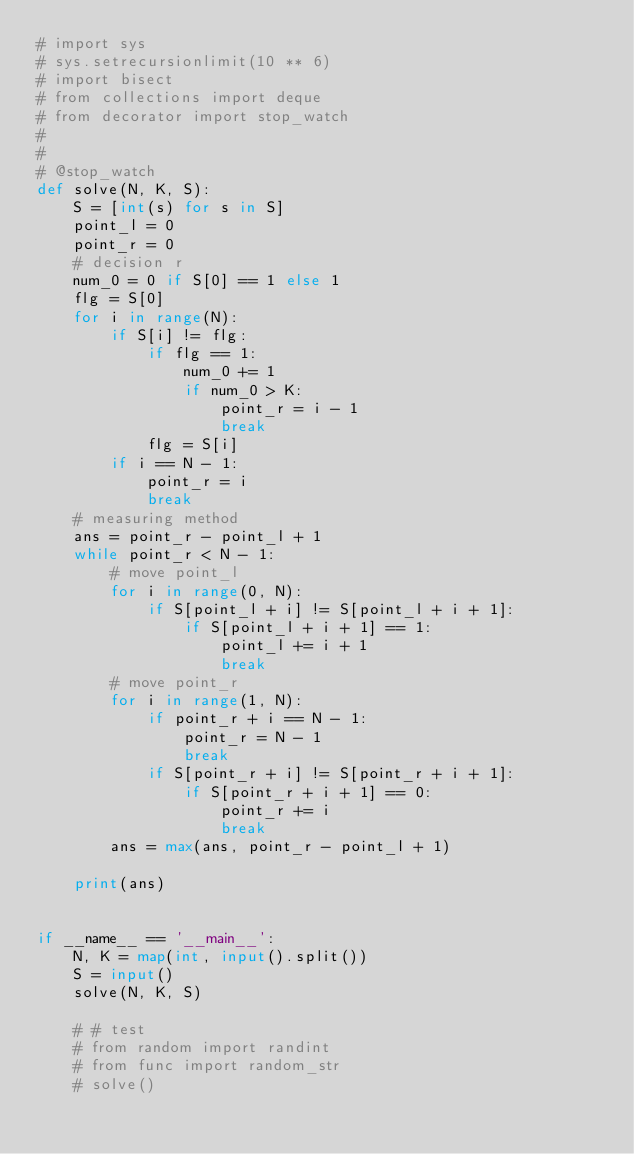<code> <loc_0><loc_0><loc_500><loc_500><_Python_># import sys
# sys.setrecursionlimit(10 ** 6)
# import bisect
# from collections import deque
# from decorator import stop_watch
# 
# 
# @stop_watch
def solve(N, K, S):
    S = [int(s) for s in S]
    point_l = 0
    point_r = 0
    # decision r
    num_0 = 0 if S[0] == 1 else 1
    flg = S[0]
    for i in range(N):
        if S[i] != flg:
            if flg == 1:
                num_0 += 1
                if num_0 > K:
                    point_r = i - 1
                    break
            flg = S[i]
        if i == N - 1:
            point_r = i
            break
    # measuring method
    ans = point_r - point_l + 1
    while point_r < N - 1:
        # move point_l
        for i in range(0, N):
            if S[point_l + i] != S[point_l + i + 1]:
                if S[point_l + i + 1] == 1:
                    point_l += i + 1
                    break
        # move point_r
        for i in range(1, N):
            if point_r + i == N - 1:
                point_r = N - 1
                break
            if S[point_r + i] != S[point_r + i + 1]:
                if S[point_r + i + 1] == 0:
                    point_r += i
                    break
        ans = max(ans, point_r - point_l + 1)

    print(ans)


if __name__ == '__main__':
    N, K = map(int, input().split())
    S = input()
    solve(N, K, S)

    # # test
    # from random import randint
    # from func import random_str
    # solve()
</code> 